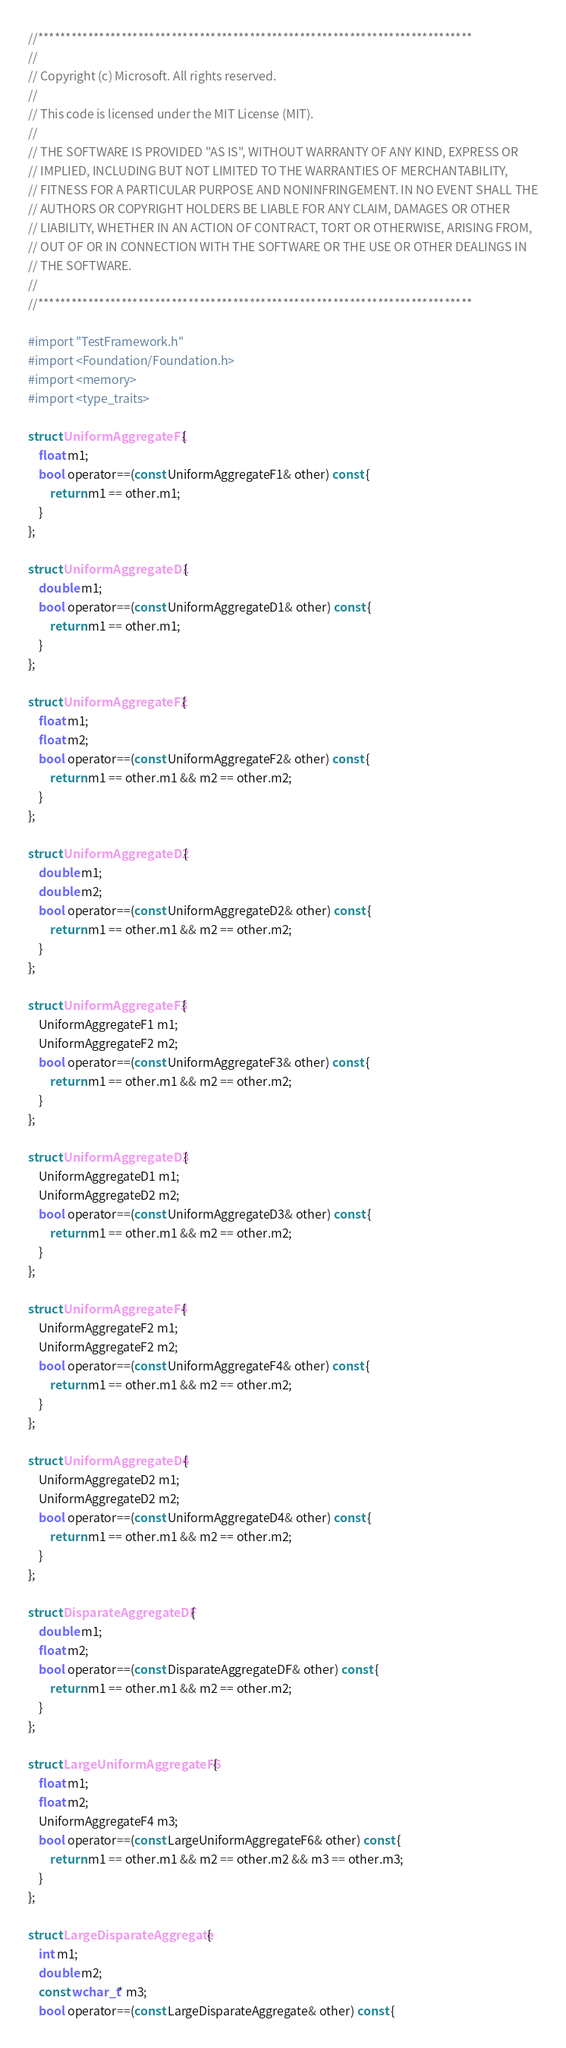Convert code to text. <code><loc_0><loc_0><loc_500><loc_500><_ObjectiveC_>//******************************************************************************
//
// Copyright (c) Microsoft. All rights reserved.
//
// This code is licensed under the MIT License (MIT).
//
// THE SOFTWARE IS PROVIDED "AS IS", WITHOUT WARRANTY OF ANY KIND, EXPRESS OR
// IMPLIED, INCLUDING BUT NOT LIMITED TO THE WARRANTIES OF MERCHANTABILITY,
// FITNESS FOR A PARTICULAR PURPOSE AND NONINFRINGEMENT. IN NO EVENT SHALL THE
// AUTHORS OR COPYRIGHT HOLDERS BE LIABLE FOR ANY CLAIM, DAMAGES OR OTHER
// LIABILITY, WHETHER IN AN ACTION OF CONTRACT, TORT OR OTHERWISE, ARISING FROM,
// OUT OF OR IN CONNECTION WITH THE SOFTWARE OR THE USE OR OTHER DEALINGS IN
// THE SOFTWARE.
//
//******************************************************************************

#import "TestFramework.h"
#import <Foundation/Foundation.h>
#import <memory>
#import <type_traits>

struct UniformAggregateF1 {
    float m1;
    bool operator==(const UniformAggregateF1& other) const {
        return m1 == other.m1;
    }
};

struct UniformAggregateD1 {
    double m1;
    bool operator==(const UniformAggregateD1& other) const {
        return m1 == other.m1;
    }
};

struct UniformAggregateF2 {
    float m1;
    float m2;
    bool operator==(const UniformAggregateF2& other) const {
        return m1 == other.m1 && m2 == other.m2;
    }
};

struct UniformAggregateD2 {
    double m1;
    double m2;
    bool operator==(const UniformAggregateD2& other) const {
        return m1 == other.m1 && m2 == other.m2;
    }
};

struct UniformAggregateF3 {
    UniformAggregateF1 m1;
    UniformAggregateF2 m2;
    bool operator==(const UniformAggregateF3& other) const {
        return m1 == other.m1 && m2 == other.m2;
    }
};

struct UniformAggregateD3 {
    UniformAggregateD1 m1;
    UniformAggregateD2 m2;
    bool operator==(const UniformAggregateD3& other) const {
        return m1 == other.m1 && m2 == other.m2;
    }
};

struct UniformAggregateF4 {
    UniformAggregateF2 m1;
    UniformAggregateF2 m2;
    bool operator==(const UniformAggregateF4& other) const {
        return m1 == other.m1 && m2 == other.m2;
    }
};

struct UniformAggregateD4 {
    UniformAggregateD2 m1;
    UniformAggregateD2 m2;
    bool operator==(const UniformAggregateD4& other) const {
        return m1 == other.m1 && m2 == other.m2;
    }
};

struct DisparateAggregateDF {
    double m1;
    float m2;
    bool operator==(const DisparateAggregateDF& other) const {
        return m1 == other.m1 && m2 == other.m2;
    }
};

struct LargeUniformAggregateF6 {
    float m1;
    float m2;
    UniformAggregateF4 m3;
    bool operator==(const LargeUniformAggregateF6& other) const {
        return m1 == other.m1 && m2 == other.m2 && m3 == other.m3;
    }
};

struct LargeDisparateAggregate {
    int m1;
    double m2;
    const wchar_t* m3;
    bool operator==(const LargeDisparateAggregate& other) const {</code> 